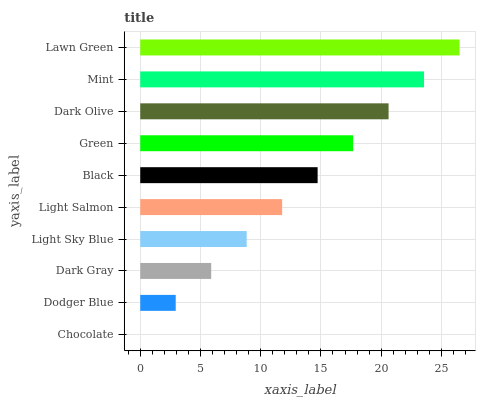Is Chocolate the minimum?
Answer yes or no. Yes. Is Lawn Green the maximum?
Answer yes or no. Yes. Is Dodger Blue the minimum?
Answer yes or no. No. Is Dodger Blue the maximum?
Answer yes or no. No. Is Dodger Blue greater than Chocolate?
Answer yes or no. Yes. Is Chocolate less than Dodger Blue?
Answer yes or no. Yes. Is Chocolate greater than Dodger Blue?
Answer yes or no. No. Is Dodger Blue less than Chocolate?
Answer yes or no. No. Is Black the high median?
Answer yes or no. Yes. Is Light Salmon the low median?
Answer yes or no. Yes. Is Lawn Green the high median?
Answer yes or no. No. Is Black the low median?
Answer yes or no. No. 